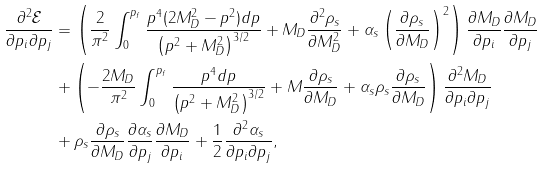Convert formula to latex. <formula><loc_0><loc_0><loc_500><loc_500>\frac { \partial ^ { 2 } \mathcal { E } } { \partial p _ { i } \partial p _ { j } } & = \left ( \frac { 2 } { \pi ^ { 2 } } \int _ { 0 } ^ { p _ { f } } { \frac { p ^ { 4 } ( 2 M _ { D } ^ { 2 } - p ^ { 2 } ) d p } { \left ( p ^ { 2 } + M _ { D } ^ { 2 } \right ) ^ { 3 / 2 } } } + M _ { D } \frac { \partial ^ { 2 } \rho _ { s } } { \partial M _ { D } ^ { 2 } } + \alpha _ { s } \left ( \frac { \partial \rho _ { s } } { \partial M _ { D } } \right ) ^ { 2 } \right ) \frac { \partial M _ { D } } { \partial p _ { i } } \frac { \partial M _ { D } } { \partial p _ { j } } \\ & + \left ( - \frac { 2 M _ { D } } { \pi ^ { 2 } } \int _ { 0 } ^ { p _ { f } } { \frac { p ^ { 4 } d p } { \left ( p ^ { 2 } + M _ { D } ^ { 2 } \right ) ^ { 3 / 2 } } } + M \frac { \partial \rho _ { s } } { \partial M _ { D } } + \alpha _ { s } \rho _ { s } \frac { \partial \rho _ { s } } { \partial M _ { D } } \right ) \frac { \partial ^ { 2 } M _ { D } } { \partial p _ { i } \partial p _ { j } } \\ & + \rho _ { s } \frac { \partial \rho _ { s } } { \partial M _ { D } } \frac { \partial \alpha _ { s } } { \partial p _ { j } } \frac { \partial M _ { D } } { \partial p _ { i } } + \frac { 1 } { 2 } \frac { \partial ^ { 2 } \alpha _ { s } } { \partial p _ { i } \partial p _ { j } } ,</formula> 